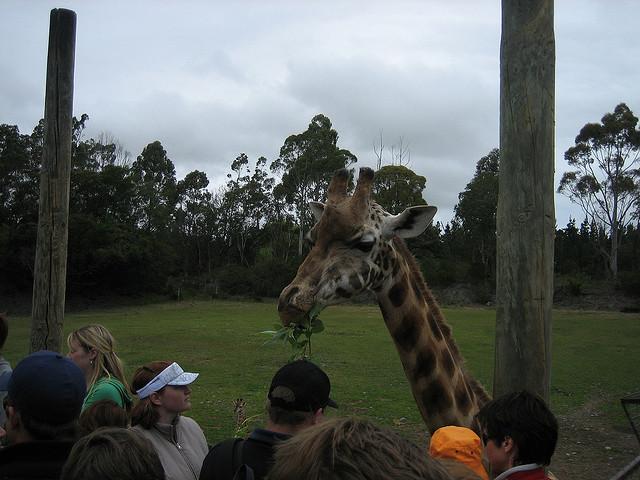Could lightning be observable on a day like this?
Keep it brief. Yes. Is the person in the white visor smiling?
Answer briefly. No. What do you think that giraffe is thinking?
Keep it brief. Hungry. 